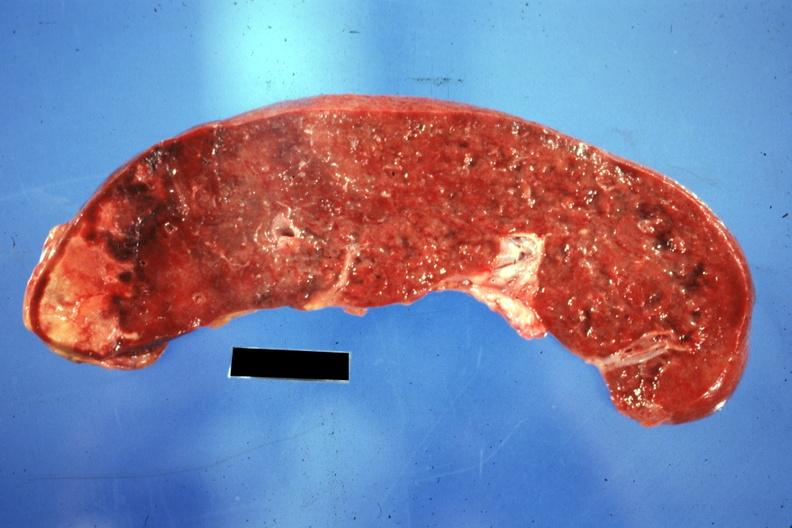does this image show cut surface of spleen with one large infarct classical embolus from nonbacterial endocarditis on mitral valve?
Answer the question using a single word or phrase. Yes 